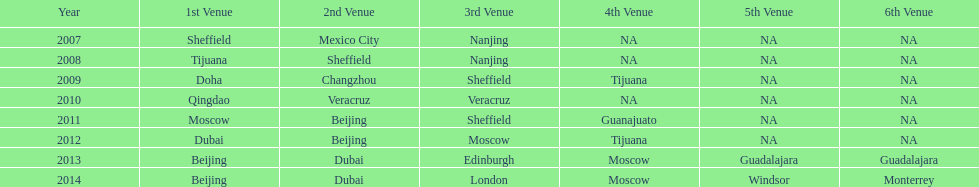In what year was the 3rd venue the same as 2011's 1st venue? 2012. 